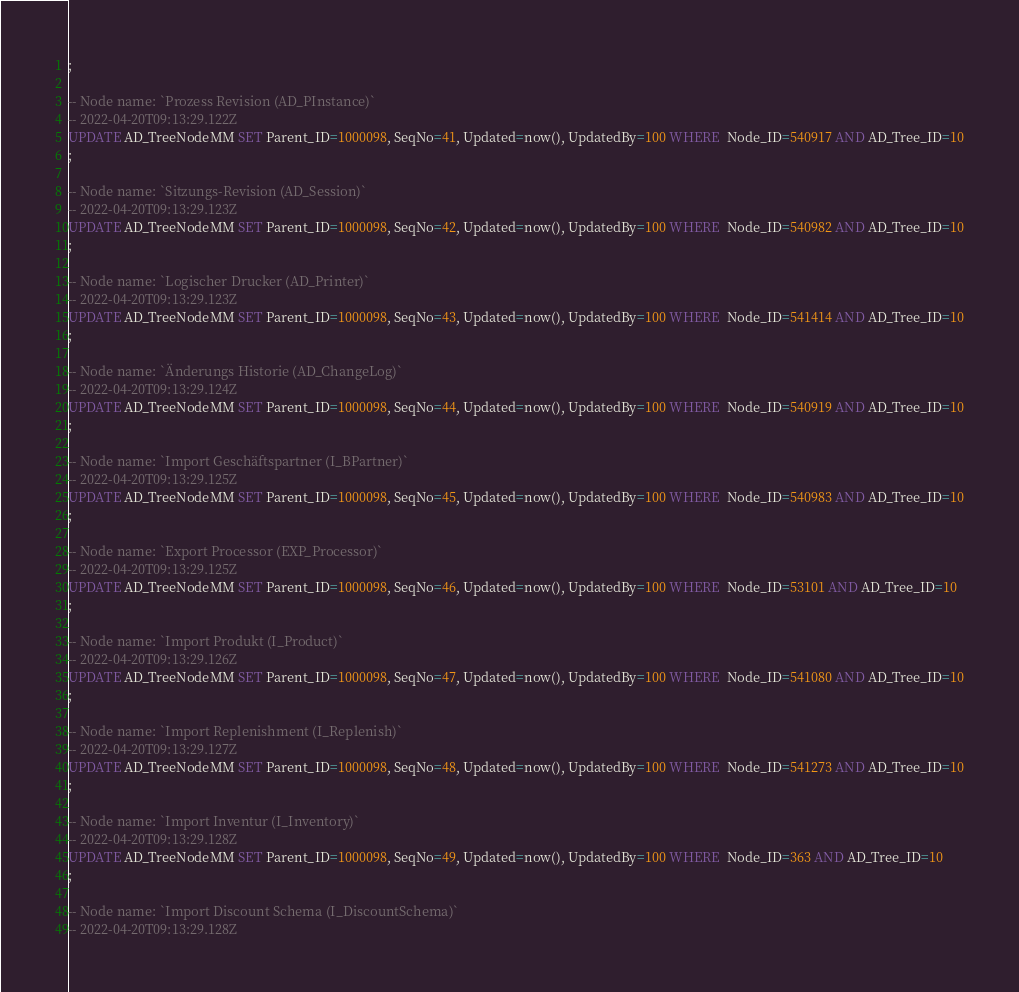<code> <loc_0><loc_0><loc_500><loc_500><_SQL_>;

-- Node name: `Prozess Revision (AD_PInstance)`
-- 2022-04-20T09:13:29.122Z
UPDATE AD_TreeNodeMM SET Parent_ID=1000098, SeqNo=41, Updated=now(), UpdatedBy=100 WHERE  Node_ID=540917 AND AD_Tree_ID=10
;

-- Node name: `Sitzungs-Revision (AD_Session)`
-- 2022-04-20T09:13:29.123Z
UPDATE AD_TreeNodeMM SET Parent_ID=1000098, SeqNo=42, Updated=now(), UpdatedBy=100 WHERE  Node_ID=540982 AND AD_Tree_ID=10
;

-- Node name: `Logischer Drucker (AD_Printer)`
-- 2022-04-20T09:13:29.123Z
UPDATE AD_TreeNodeMM SET Parent_ID=1000098, SeqNo=43, Updated=now(), UpdatedBy=100 WHERE  Node_ID=541414 AND AD_Tree_ID=10
;

-- Node name: `Änderungs Historie (AD_ChangeLog)`
-- 2022-04-20T09:13:29.124Z
UPDATE AD_TreeNodeMM SET Parent_ID=1000098, SeqNo=44, Updated=now(), UpdatedBy=100 WHERE  Node_ID=540919 AND AD_Tree_ID=10
;

-- Node name: `Import Geschäftspartner (I_BPartner)`
-- 2022-04-20T09:13:29.125Z
UPDATE AD_TreeNodeMM SET Parent_ID=1000098, SeqNo=45, Updated=now(), UpdatedBy=100 WHERE  Node_ID=540983 AND AD_Tree_ID=10
;

-- Node name: `Export Processor (EXP_Processor)`
-- 2022-04-20T09:13:29.125Z
UPDATE AD_TreeNodeMM SET Parent_ID=1000098, SeqNo=46, Updated=now(), UpdatedBy=100 WHERE  Node_ID=53101 AND AD_Tree_ID=10
;

-- Node name: `Import Produkt (I_Product)`
-- 2022-04-20T09:13:29.126Z
UPDATE AD_TreeNodeMM SET Parent_ID=1000098, SeqNo=47, Updated=now(), UpdatedBy=100 WHERE  Node_ID=541080 AND AD_Tree_ID=10
;

-- Node name: `Import Replenishment (I_Replenish)`
-- 2022-04-20T09:13:29.127Z
UPDATE AD_TreeNodeMM SET Parent_ID=1000098, SeqNo=48, Updated=now(), UpdatedBy=100 WHERE  Node_ID=541273 AND AD_Tree_ID=10
;

-- Node name: `Import Inventur (I_Inventory)`
-- 2022-04-20T09:13:29.128Z
UPDATE AD_TreeNodeMM SET Parent_ID=1000098, SeqNo=49, Updated=now(), UpdatedBy=100 WHERE  Node_ID=363 AND AD_Tree_ID=10
;

-- Node name: `Import Discount Schema (I_DiscountSchema)`
-- 2022-04-20T09:13:29.128Z</code> 